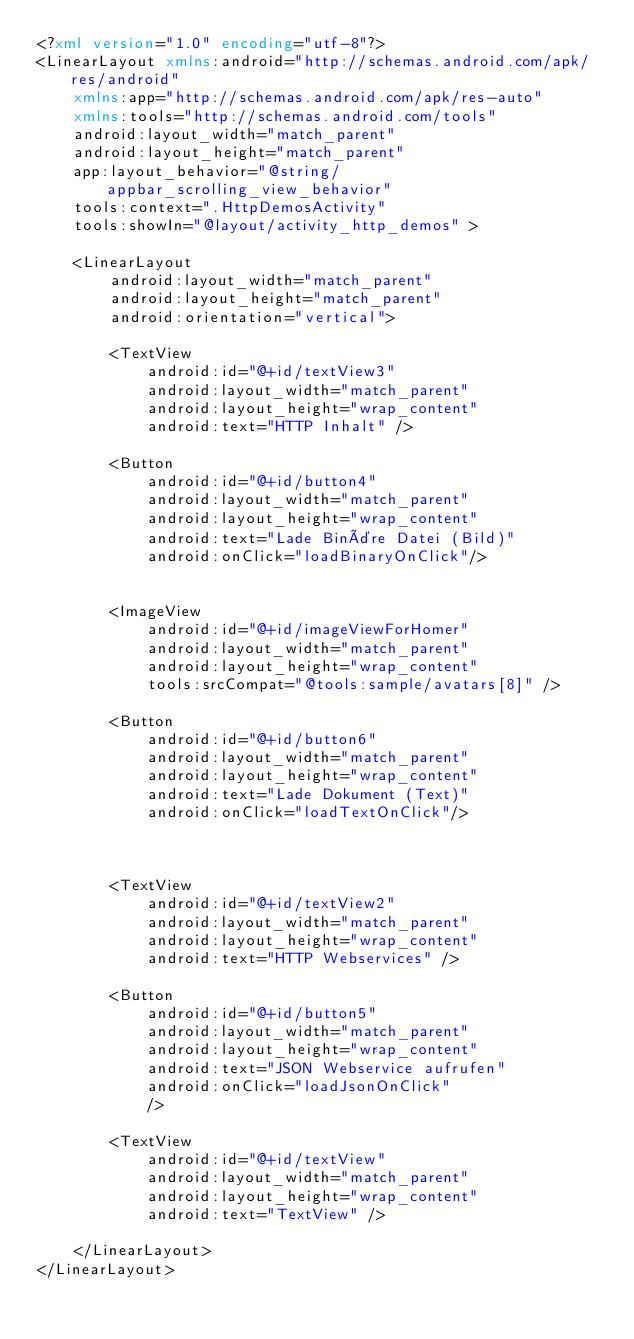Convert code to text. <code><loc_0><loc_0><loc_500><loc_500><_XML_><?xml version="1.0" encoding="utf-8"?>
<LinearLayout xmlns:android="http://schemas.android.com/apk/res/android"
    xmlns:app="http://schemas.android.com/apk/res-auto"
    xmlns:tools="http://schemas.android.com/tools"
    android:layout_width="match_parent"
    android:layout_height="match_parent"
    app:layout_behavior="@string/appbar_scrolling_view_behavior"
    tools:context=".HttpDemosActivity"
    tools:showIn="@layout/activity_http_demos" >

    <LinearLayout
        android:layout_width="match_parent"
        android:layout_height="match_parent"
        android:orientation="vertical">

        <TextView
            android:id="@+id/textView3"
            android:layout_width="match_parent"
            android:layout_height="wrap_content"
            android:text="HTTP Inhalt" />

        <Button
            android:id="@+id/button4"
            android:layout_width="match_parent"
            android:layout_height="wrap_content"
            android:text="Lade Binäre Datei (Bild)"
            android:onClick="loadBinaryOnClick"/>


        <ImageView
            android:id="@+id/imageViewForHomer"
            android:layout_width="match_parent"
            android:layout_height="wrap_content"
            tools:srcCompat="@tools:sample/avatars[8]" />

        <Button
            android:id="@+id/button6"
            android:layout_width="match_parent"
            android:layout_height="wrap_content"
            android:text="Lade Dokument (Text)"
            android:onClick="loadTextOnClick"/>



        <TextView
            android:id="@+id/textView2"
            android:layout_width="match_parent"
            android:layout_height="wrap_content"
            android:text="HTTP Webservices" />

        <Button
            android:id="@+id/button5"
            android:layout_width="match_parent"
            android:layout_height="wrap_content"
            android:text="JSON Webservice aufrufen"
            android:onClick="loadJsonOnClick"
            />

        <TextView
            android:id="@+id/textView"
            android:layout_width="match_parent"
            android:layout_height="wrap_content"
            android:text="TextView" />

    </LinearLayout>
</LinearLayout></code> 